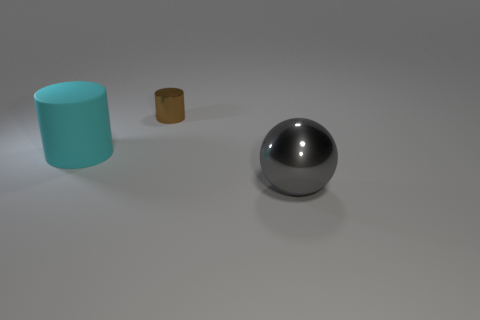Add 1 large balls. How many objects exist? 4 Subtract all spheres. How many objects are left? 2 Subtract all small metallic things. Subtract all large gray metal things. How many objects are left? 1 Add 1 big rubber cylinders. How many big rubber cylinders are left? 2 Add 2 balls. How many balls exist? 3 Subtract 1 brown cylinders. How many objects are left? 2 